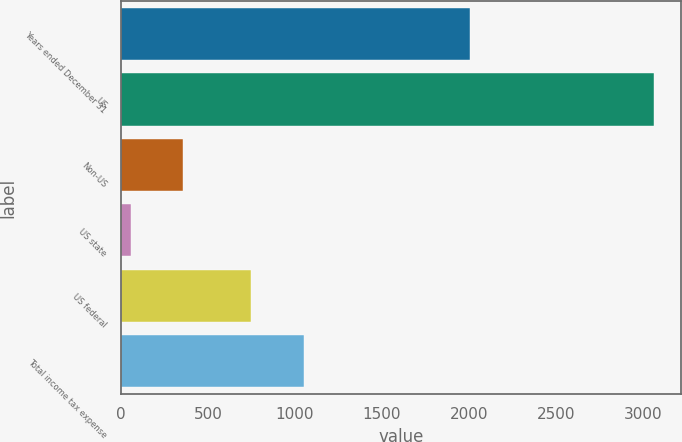Convert chart to OTSL. <chart><loc_0><loc_0><loc_500><loc_500><bar_chart><fcel>Years ended December 31<fcel>US<fcel>Non-US<fcel>US state<fcel>US federal<fcel>Total income tax expense<nl><fcel>2006<fcel>3067<fcel>358.9<fcel>58<fcel>750<fcel>1050.9<nl></chart> 